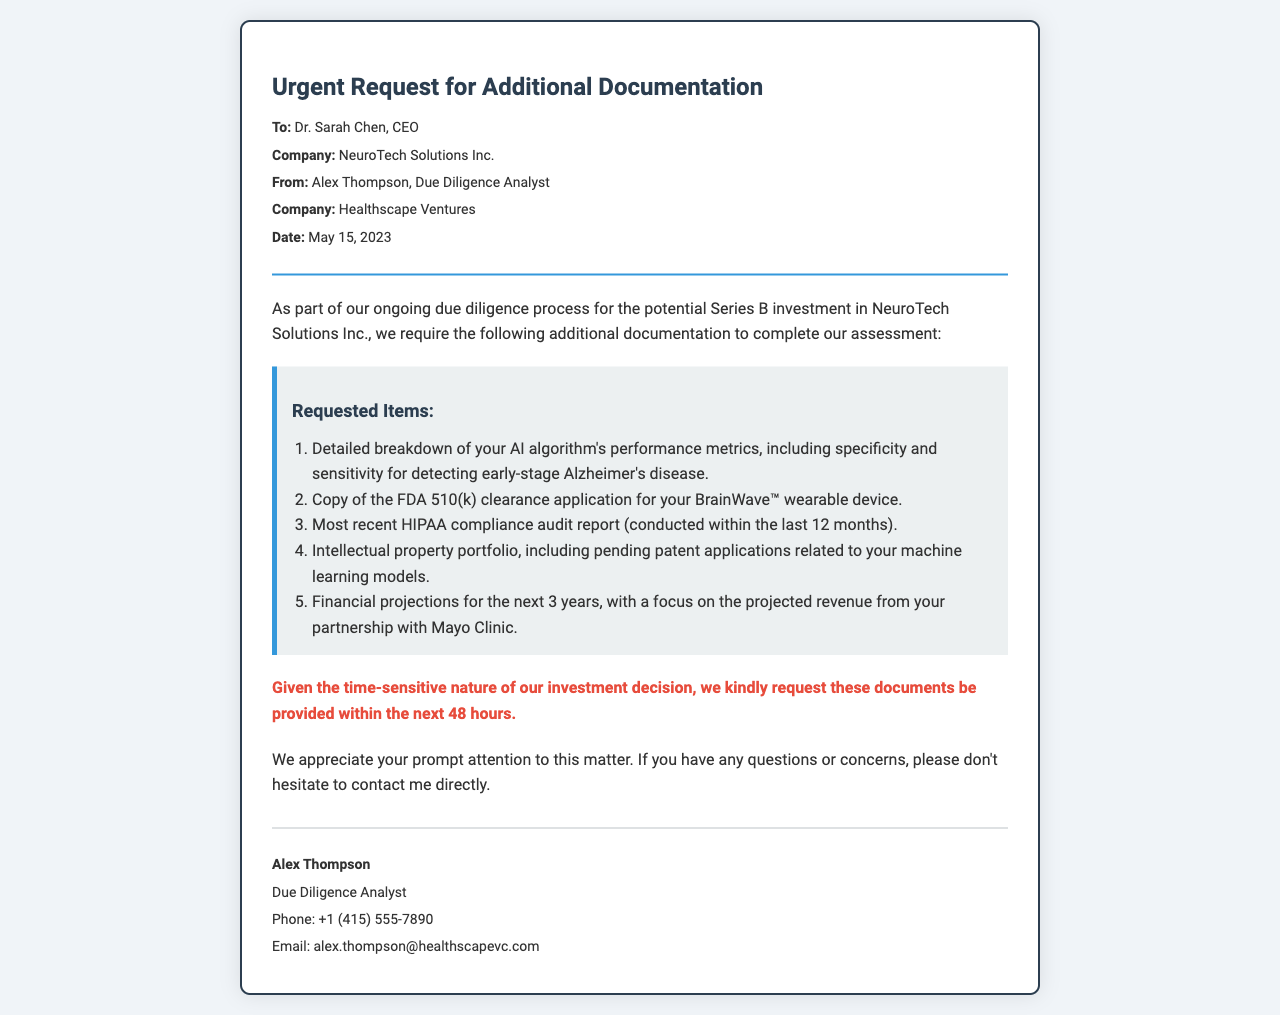What is the name of the CEO? The document states that the CEO is Dr. Sarah Chen.
Answer: Dr. Sarah Chen What is the date of the request? The request is dated May 15, 2023.
Answer: May 15, 2023 How many items are requested in total? There are five requested items listed in the document.
Answer: 5 What type of device is mentioned in the request? The document references the BrainWave™ wearable device.
Answer: BrainWave™ Who is the analyst sending the request? The request is sent by Alex Thompson, the Due Diligence Analyst.
Answer: Alex Thompson What is the urgency for the requested documents? The documents are requested within the next 48 hours.
Answer: 48 hours What is one of the compliance documents requested? A HIPAA compliance audit report is requested.
Answer: HIPAA compliance audit report Which clinic is mentioned in relation to revenue projections? The Mayo Clinic is referenced regarding projected revenue.
Answer: Mayo Clinic 